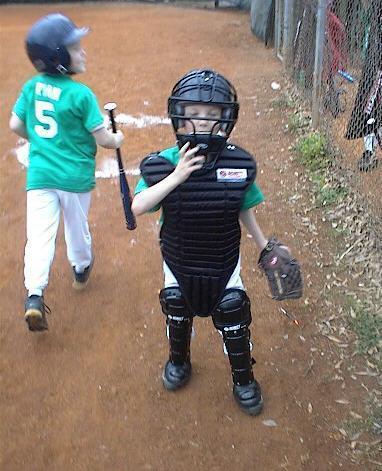How many people are pictured?
Give a very brief answer. 2. How many people have helmets on?
Give a very brief answer. 1. How many people are there?
Give a very brief answer. 2. How many chairs are facing the far wall?
Give a very brief answer. 0. 